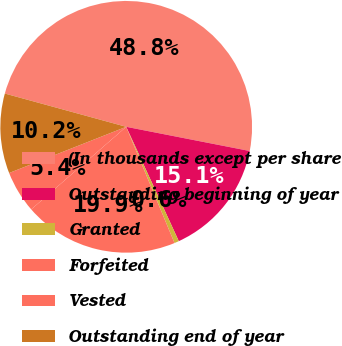<chart> <loc_0><loc_0><loc_500><loc_500><pie_chart><fcel>(In thousands except per share<fcel>Outstanding beginning of year<fcel>Granted<fcel>Forfeited<fcel>Vested<fcel>Outstanding end of year<nl><fcel>48.82%<fcel>15.06%<fcel>0.59%<fcel>19.88%<fcel>5.41%<fcel>10.24%<nl></chart> 